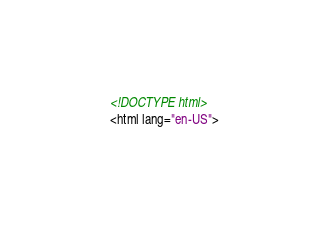Convert code to text. <code><loc_0><loc_0><loc_500><loc_500><_HTML_>
<!DOCTYPE html>
<html lang="en-US">
</code> 